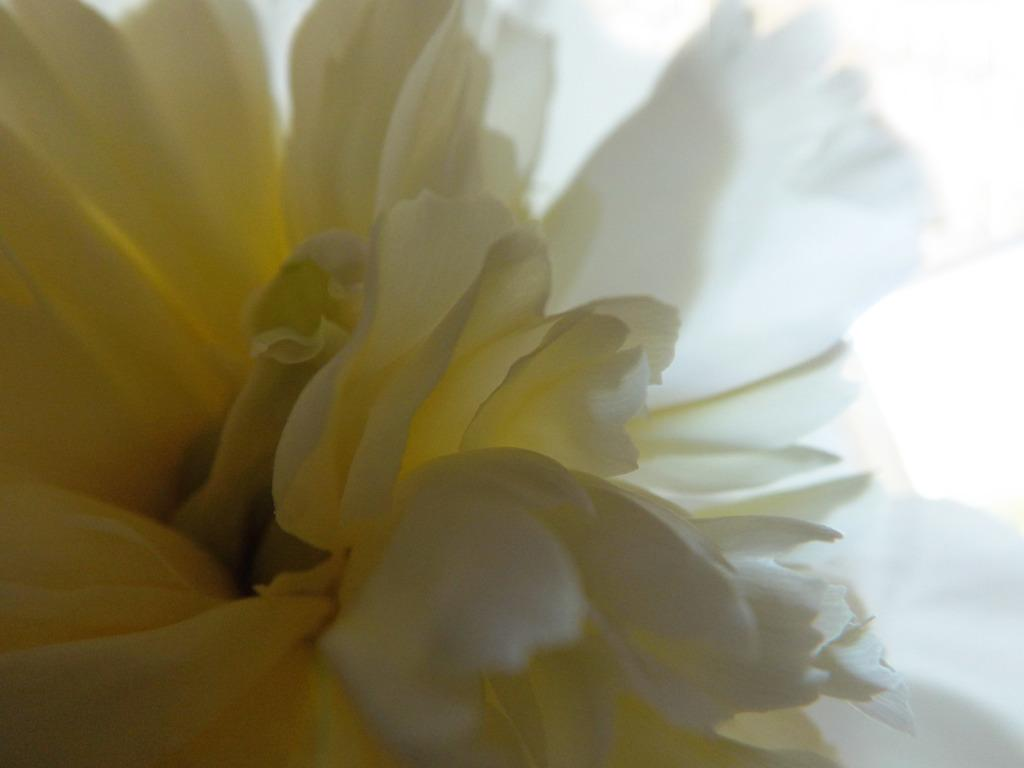What type of flower is present in the image? There is a white flower in the image. Can you see any pickles growing on the flower in the image? There are no pickles present in the image, as it features a white flower. Is there any indication of a mine or mining activity in the image? There is no indication of a mine or mining activity in the image, as it features a white flower. Are there any stockings visible in the image? There are no stockings present in the image, as it features a white flower. 